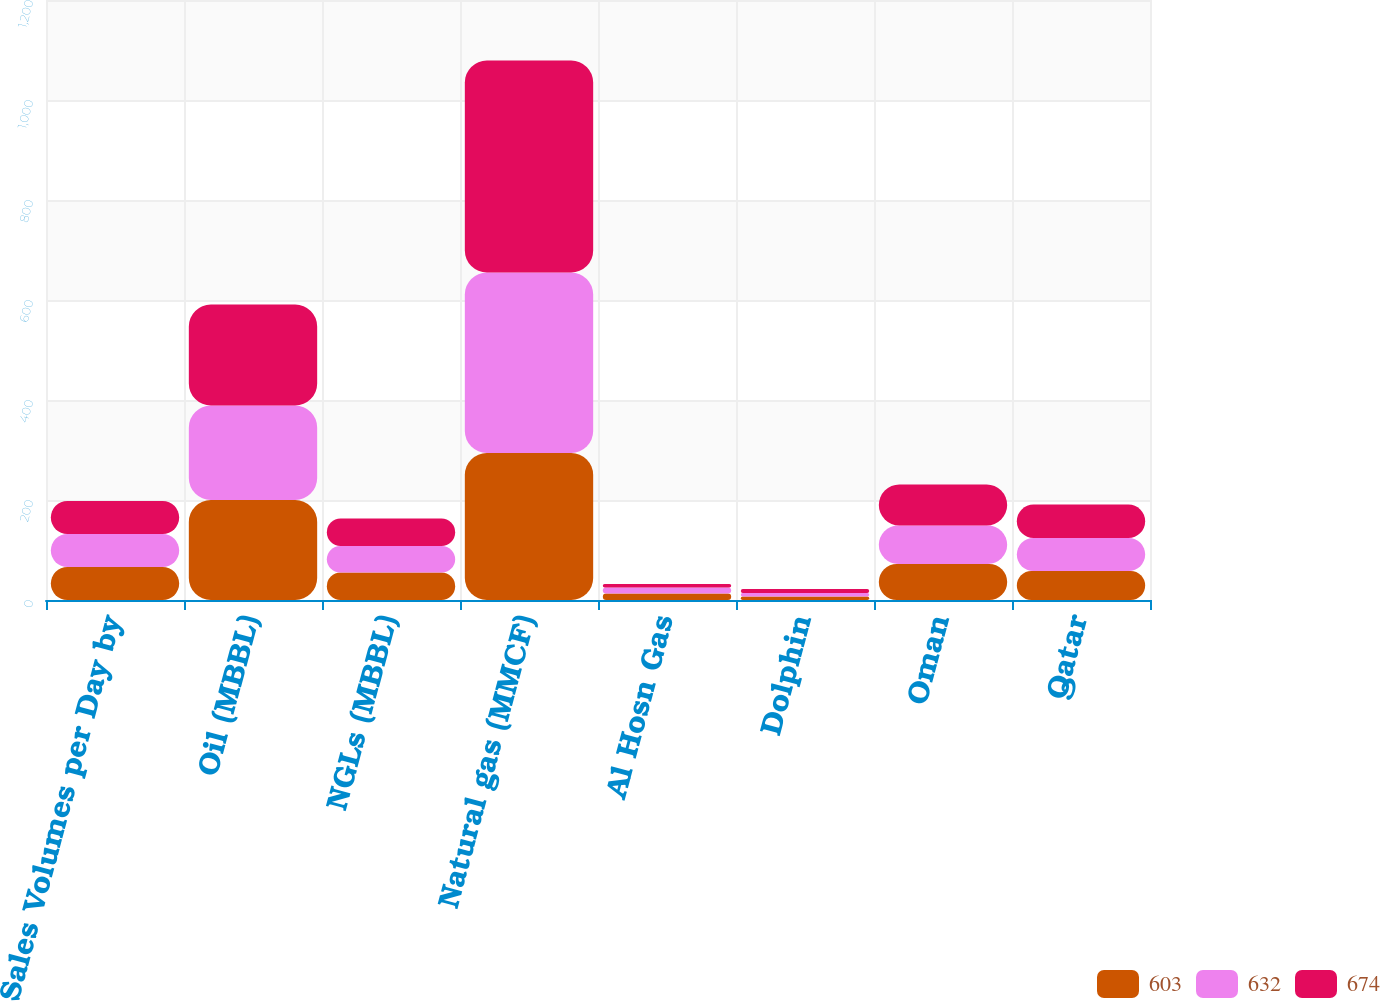Convert chart to OTSL. <chart><loc_0><loc_0><loc_500><loc_500><stacked_bar_chart><ecel><fcel>Sales Volumes per Day by<fcel>Oil (MBBL)<fcel>NGLs (MBBL)<fcel>Natural gas (MMCF)<fcel>Al Hosn Gas<fcel>Dolphin<fcel>Oman<fcel>Qatar<nl><fcel>603<fcel>66<fcel>200<fcel>55<fcel>294<fcel>13<fcel>7<fcel>72<fcel>58<nl><fcel>632<fcel>66<fcel>189<fcel>53<fcel>361<fcel>12<fcel>7<fcel>77<fcel>66<nl><fcel>674<fcel>66<fcel>202<fcel>55<fcel>424<fcel>7<fcel>8<fcel>82<fcel>67<nl></chart> 